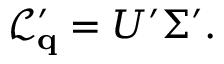<formula> <loc_0><loc_0><loc_500><loc_500>\begin{array} { r } { { \mathcal { L } _ { \mathbf q } ^ { \prime } } = U ^ { \prime } \Sigma ^ { \prime } . } \end{array}</formula> 